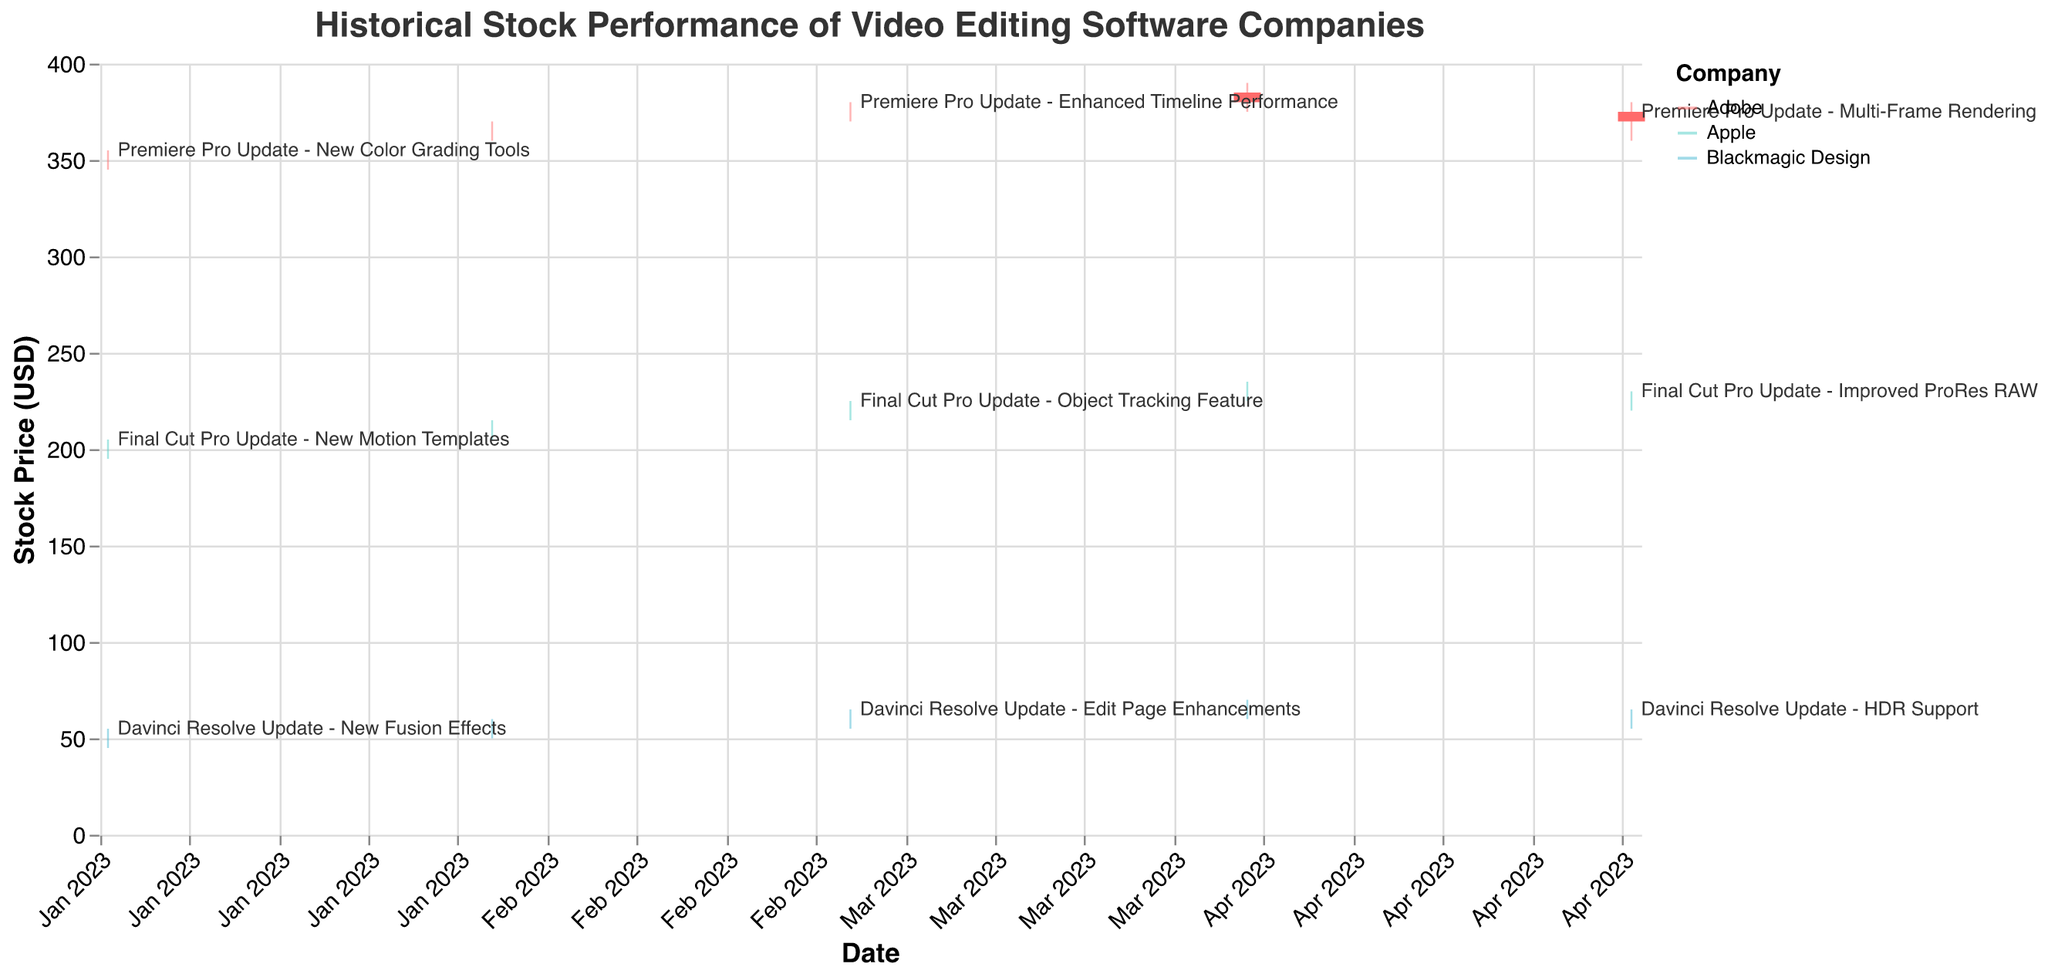What is the title of the figure? The title of the figure is usually located at the top of the chart. It provides a brief description of what the chart represents.
Answer: Historical Stock Performance of Video Editing Software Companies How many companies are represented in the figure? The figure includes data from three companies, each represented by different colors in the plot. The colors assigned in the legend are checked to determine this.
Answer: Three What was Adobe's closing stock price in April 2023? Move to the data points corresponding to April 2023 with the color and labels representing Adobe. Look for the 'Close' value.
Answer: 380 How did Apple's stock price respond to the update in March 2023? Look at the candlestick for March 2023. Check for any significant patterns such as increase or decrease in prices from 'Open' to 'Close'.
Answer: It increased, opening at 220 and closing at 220 Which company had the most significant price difference between 'High' and 'Low' in any single month, and what was the value? For each company, calculate the difference (High - Low) for each month. Compare all differences to find the maximum. Adobe: (355-345)=10 in Jan 2023, Apple: (230-225)=10 in Apr 2023, Blackmagic Design: (70-60)=10 in Apr 2023.
Answer: Adobe, Apple, and Blackmagic Design each had a maximum difference of 10 Which company experienced the highest volume of trade in May 2023? Check the column for May 2023, identify which company's 'Volume' is the largest among the three in that specific month. Compare these volumes: Adobe: 1700000, Apple: 1000000, Blackmagic Design: 500000.
Answer: Adobe On which dates did Adobe release significant updates, and how did these updates affect the stock prices? Look for the dates associated with Adobe and significant events in the 'Event' column. Identify the 'Open' and 'Close' prices for each date to see if there was an increase or decrease. – Premiere Pro Update - New Color Grading Tools (Jan 2023): No change: Open 350, Close 350; Enhanced Timeline Performance (Mar 2023): Small increase: Open 375, Close 375; Multi-Frame Rendering (May 2023): Decrease: Open 375, Close 370.
Answer: Jan 2023: No change, Mar 2023: Small increase, May 2023: Decrease How do Blackmagic Design and Apple’s stock prices compare in March 2023? Look at the candlestick for March 2023 for both companies; compare the 'Open', 'Close', 'High', and 'Low' values. Blackmagic Design opened at 60 and closed at 60. Apple opened at 220 and closed at 220.
Answer: Both companies opened and closed with the same price in March 2023 What was the trend in Adobe's stock prices over the first five months of 2023? Observe the 'Close' prices for Adobe from January to May 2023. Identify if there's an increasing or decreasing pattern.
Answer: Generally increasing from 350 to 375, then decreasing to 370 How did the volume of trade for Blackmagic Design change from January to May 2023? Look at the 'Volume' values for Blackmagic Design over these months and track the changes. Volumes: Jan 300000, Feb 350000, Mar 400000, Apr 450000, May 500000.
Answer: Steadily increasing from 300,000 to 500,000 